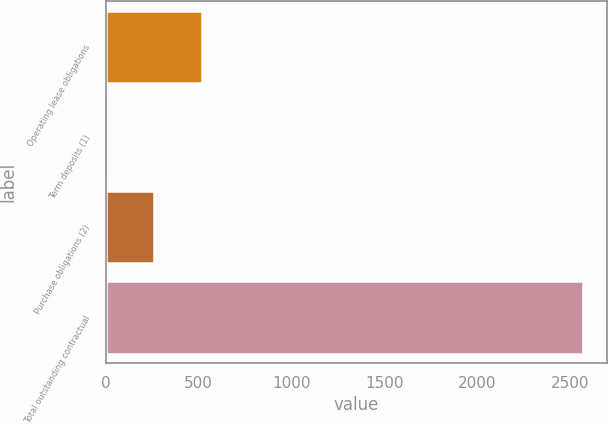<chart> <loc_0><loc_0><loc_500><loc_500><bar_chart><fcel>Operating lease obligations<fcel>Term deposits (1)<fcel>Purchase obligations (2)<fcel>Total outstanding contractual<nl><fcel>519.2<fcel>7<fcel>263.1<fcel>2568<nl></chart> 